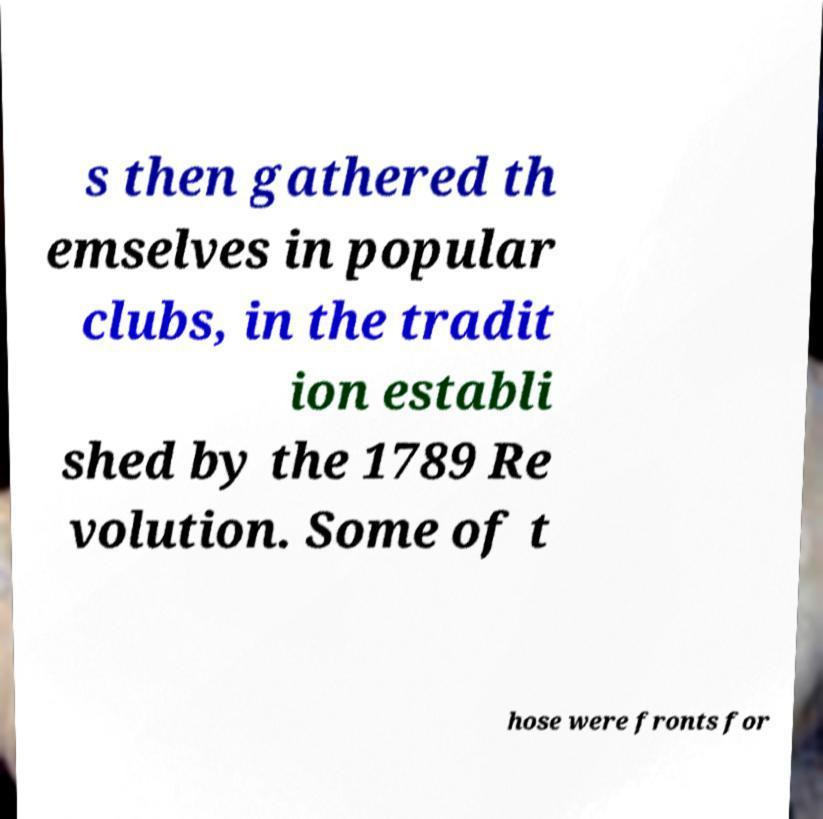For documentation purposes, I need the text within this image transcribed. Could you provide that? s then gathered th emselves in popular clubs, in the tradit ion establi shed by the 1789 Re volution. Some of t hose were fronts for 